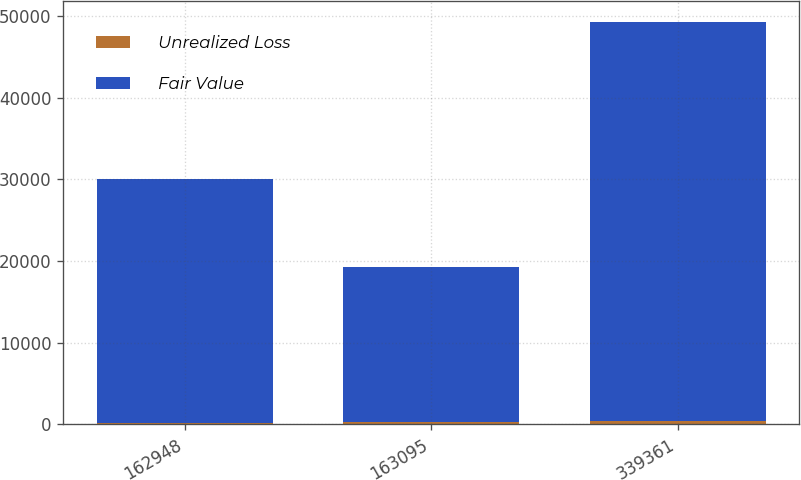Convert chart to OTSL. <chart><loc_0><loc_0><loc_500><loc_500><stacked_bar_chart><ecel><fcel>162948<fcel>163095<fcel>339361<nl><fcel>Unrealized Loss<fcel>142<fcel>219<fcel>370<nl><fcel>Fair Value<fcel>29942<fcel>19021<fcel>48963<nl></chart> 